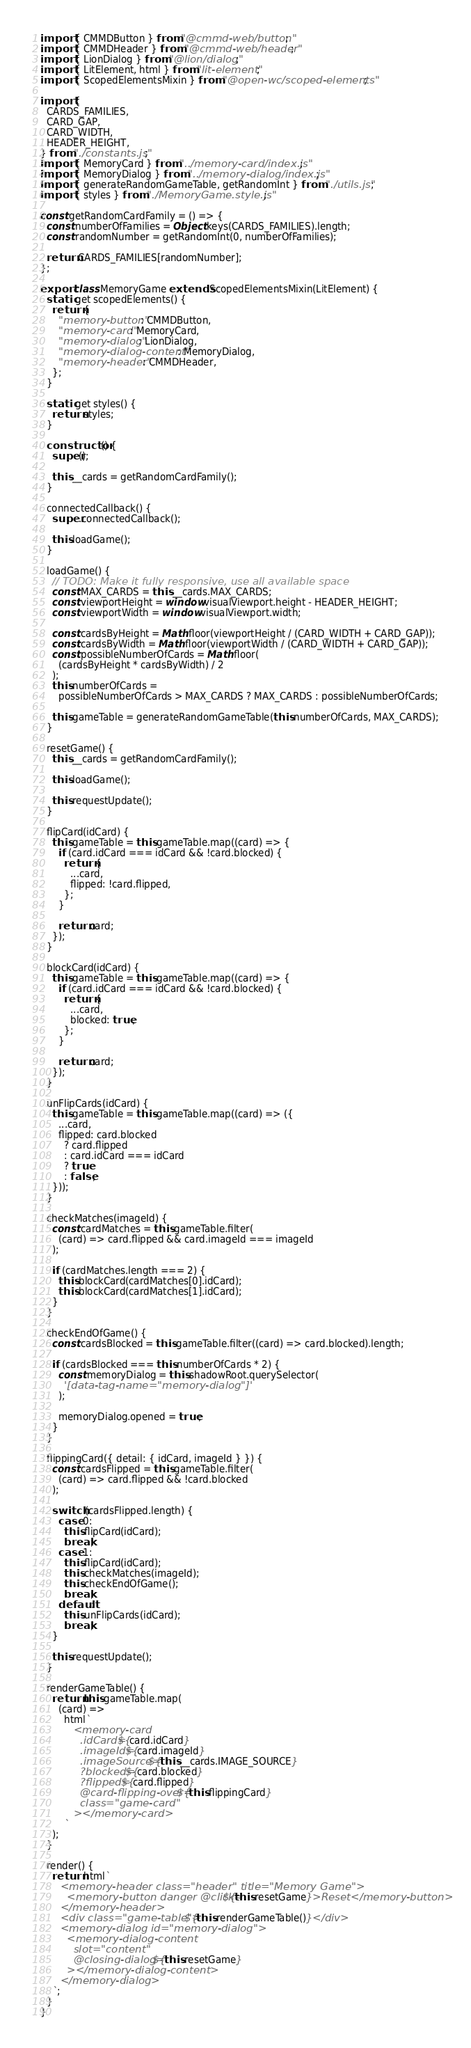<code> <loc_0><loc_0><loc_500><loc_500><_JavaScript_>import { CMMDButton } from "@cmmd-web/button";
import { CMMDHeader } from "@cmmd-web/header";
import { LionDialog } from "@lion/dialog";
import { LitElement, html } from "lit-element";
import { ScopedElementsMixin } from "@open-wc/scoped-elements";

import {
  CARDS_FAMILIES,
  CARD_GAP,
  CARD_WIDTH,
  HEADER_HEIGHT,
} from "./constants.js";
import { MemoryCard } from "../memory-card/index.js";
import { MemoryDialog } from "../memory-dialog/index.js";
import { generateRandomGameTable, getRandomInt } from "./utils.js";
import { styles } from "./MemoryGame.style.js";

const getRandomCardFamily = () => {
  const numberOfFamilies = Object.keys(CARDS_FAMILIES).length;
  const randomNumber = getRandomInt(0, numberOfFamilies);

  return CARDS_FAMILIES[randomNumber];
};

export class MemoryGame extends ScopedElementsMixin(LitElement) {
  static get scopedElements() {
    return {
      "memory-button": CMMDButton,
      "memory-card": MemoryCard,
      "memory-dialog": LionDialog,
      "memory-dialog-content": MemoryDialog,
      "memory-header": CMMDHeader,
    };
  }

  static get styles() {
    return styles;
  }

  constructor() {
    super();

    this.__cards = getRandomCardFamily();
  }

  connectedCallback() {
    super.connectedCallback();

    this.loadGame();
  }

  loadGame() {
    // TODO: Make it fully responsive, use all available space
    const MAX_CARDS = this.__cards.MAX_CARDS;
    const viewportHeight = window.visualViewport.height - HEADER_HEIGHT;
    const viewportWidth = window.visualViewport.width;

    const cardsByHeight = Math.floor(viewportHeight / (CARD_WIDTH + CARD_GAP));
    const cardsByWidth = Math.floor(viewportWidth / (CARD_WIDTH + CARD_GAP));
    const possibleNumberOfCards = Math.floor(
      (cardsByHeight * cardsByWidth) / 2
    );
    this.numberOfCards =
      possibleNumberOfCards > MAX_CARDS ? MAX_CARDS : possibleNumberOfCards;

    this.gameTable = generateRandomGameTable(this.numberOfCards, MAX_CARDS);
  }

  resetGame() {
    this.__cards = getRandomCardFamily();
    
    this.loadGame();

    this.requestUpdate();
  }

  flipCard(idCard) {
    this.gameTable = this.gameTable.map((card) => {
      if (card.idCard === idCard && !card.blocked) {
        return {
          ...card,
          flipped: !card.flipped,
        };
      }

      return card;
    });
  }

  blockCard(idCard) {
    this.gameTable = this.gameTable.map((card) => {
      if (card.idCard === idCard && !card.blocked) {
        return {
          ...card,
          blocked: true,
        };
      }

      return card;
    });
  }

  unFlipCards(idCard) {
    this.gameTable = this.gameTable.map((card) => ({
      ...card,
      flipped: card.blocked
        ? card.flipped
        : card.idCard === idCard
        ? true
        : false,
    }));
  }

  checkMatches(imageId) {
    const cardMatches = this.gameTable.filter(
      (card) => card.flipped && card.imageId === imageId
    );

    if (cardMatches.length === 2) {
      this.blockCard(cardMatches[0].idCard);
      this.blockCard(cardMatches[1].idCard);
    }
  }

  checkEndOfGame() {
    const cardsBlocked = this.gameTable.filter((card) => card.blocked).length;

    if (cardsBlocked === this.numberOfCards * 2) {
      const memoryDialog = this.shadowRoot.querySelector(
        '[data-tag-name="memory-dialog"]'
      );

      memoryDialog.opened = true;
    }
  }

  flippingCard({ detail: { idCard, imageId } }) {
    const cardsFlipped = this.gameTable.filter(
      (card) => card.flipped && !card.blocked
    );

    switch (cardsFlipped.length) {
      case 0:
        this.flipCard(idCard);
        break;
      case 1:
        this.flipCard(idCard);
        this.checkMatches(imageId);
        this.checkEndOfGame();
        break;
      default:
        this.unFlipCards(idCard);
        break;
    }

    this.requestUpdate();
  }

  renderGameTable() {
    return this.gameTable.map(
      (card) =>
        html`
          <memory-card
            .idCard=${card.idCard}
            .imageId=${card.imageId}
            .imageSource=${this.__cards.IMAGE_SOURCE}
            ?blocked=${card.blocked}
            ?flipped=${card.flipped}
            @card-flipping-over=${this.flippingCard}
            class="game-card"
          ></memory-card>
        `
    );
  }

  render() {
    return html`
      <memory-header class="header" title="Memory Game">
        <memory-button danger @click=${this.resetGame}>Reset</memory-button>
      </memory-header>
      <div class="game-table">${this.renderGameTable()}</div>
      <memory-dialog id="memory-dialog">
        <memory-dialog-content
          slot="content"
          @closing-dialog=${this.resetGame}
        ></memory-dialog-content>
      </memory-dialog>
    `;
  }
}
</code> 